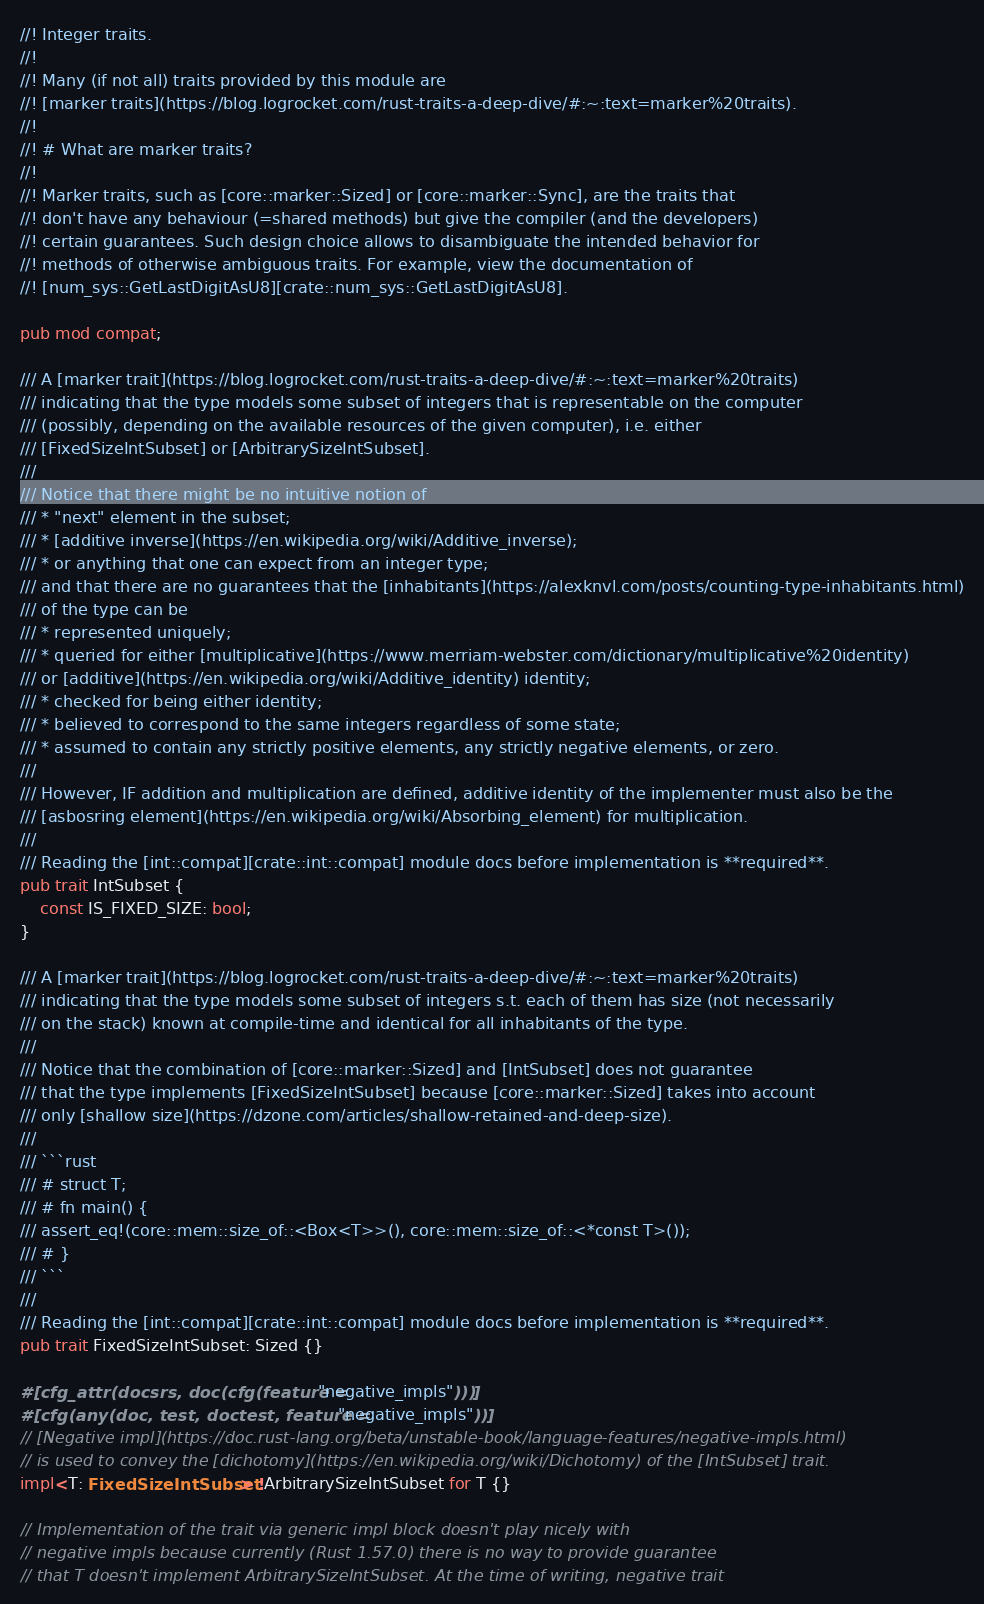Convert code to text. <code><loc_0><loc_0><loc_500><loc_500><_Rust_>//! Integer traits.
//!
//! Many (if not all) traits provided by this module are
//! [marker traits](https://blog.logrocket.com/rust-traits-a-deep-dive/#:~:text=marker%20traits).
//!
//! # What are marker traits?
//!
//! Marker traits, such as [core::marker::Sized] or [core::marker::Sync], are the traits that
//! don't have any behaviour (=shared methods) but give the compiler (and the developers)
//! certain guarantees. Such design choice allows to disambiguate the intended behavior for
//! methods of otherwise ambiguous traits. For example, view the documentation of
//! [num_sys::GetLastDigitAsU8][crate::num_sys::GetLastDigitAsU8].

pub mod compat;

/// A [marker trait](https://blog.logrocket.com/rust-traits-a-deep-dive/#:~:text=marker%20traits)
/// indicating that the type models some subset of integers that is representable on the computer
/// (possibly, depending on the available resources of the given computer), i.e. either
/// [FixedSizeIntSubset] or [ArbitrarySizeIntSubset].
///
/// Notice that there might be no intuitive notion of
/// * "next" element in the subset;
/// * [additive inverse](https://en.wikipedia.org/wiki/Additive_inverse);
/// * or anything that one can expect from an integer type;
/// and that there are no guarantees that the [inhabitants](https://alexknvl.com/posts/counting-type-inhabitants.html)
/// of the type can be
/// * represented uniquely;
/// * queried for either [multiplicative](https://www.merriam-webster.com/dictionary/multiplicative%20identity)
/// or [additive](https://en.wikipedia.org/wiki/Additive_identity) identity;
/// * checked for being either identity;
/// * believed to correspond to the same integers regardless of some state;
/// * assumed to contain any strictly positive elements, any strictly negative elements, or zero.
///
/// However, IF addition and multiplication are defined, additive identity of the implementer must also be the
/// [asbosring element](https://en.wikipedia.org/wiki/Absorbing_element) for multiplication.
///
/// Reading the [int::compat][crate::int::compat] module docs before implementation is **required**.
pub trait IntSubset {
    const IS_FIXED_SIZE: bool;
}

/// A [marker trait](https://blog.logrocket.com/rust-traits-a-deep-dive/#:~:text=marker%20traits)
/// indicating that the type models some subset of integers s.t. each of them has size (not necessarily
/// on the stack) known at compile-time and identical for all inhabitants of the type.
///
/// Notice that the combination of [core::marker::Sized] and [IntSubset] does not guarantee
/// that the type implements [FixedSizeIntSubset] because [core::marker::Sized] takes into account
/// only [shallow size](https://dzone.com/articles/shallow-retained-and-deep-size).
///
/// ```rust
/// # struct T;
/// # fn main() {
/// assert_eq!(core::mem::size_of::<Box<T>>(), core::mem::size_of::<*const T>());
/// # }
/// ```
///
/// Reading the [int::compat][crate::int::compat] module docs before implementation is **required**.
pub trait FixedSizeIntSubset: Sized {}

#[cfg_attr(docsrs, doc(cfg(feature = "negative_impls")))]
#[cfg(any(doc, test, doctest, feature = "negative_impls"))]
// [Negative impl](https://doc.rust-lang.org/beta/unstable-book/language-features/negative-impls.html)
// is used to convey the [dichotomy](https://en.wikipedia.org/wiki/Dichotomy) of the [IntSubset] trait.
impl<T: FixedSizeIntSubset> !ArbitrarySizeIntSubset for T {}

// Implementation of the trait via generic impl block doesn't play nicely with
// negative impls because currently (Rust 1.57.0) there is no way to provide guarantee
// that T doesn't implement ArbitrarySizeIntSubset. At the time of writing, negative trait</code> 